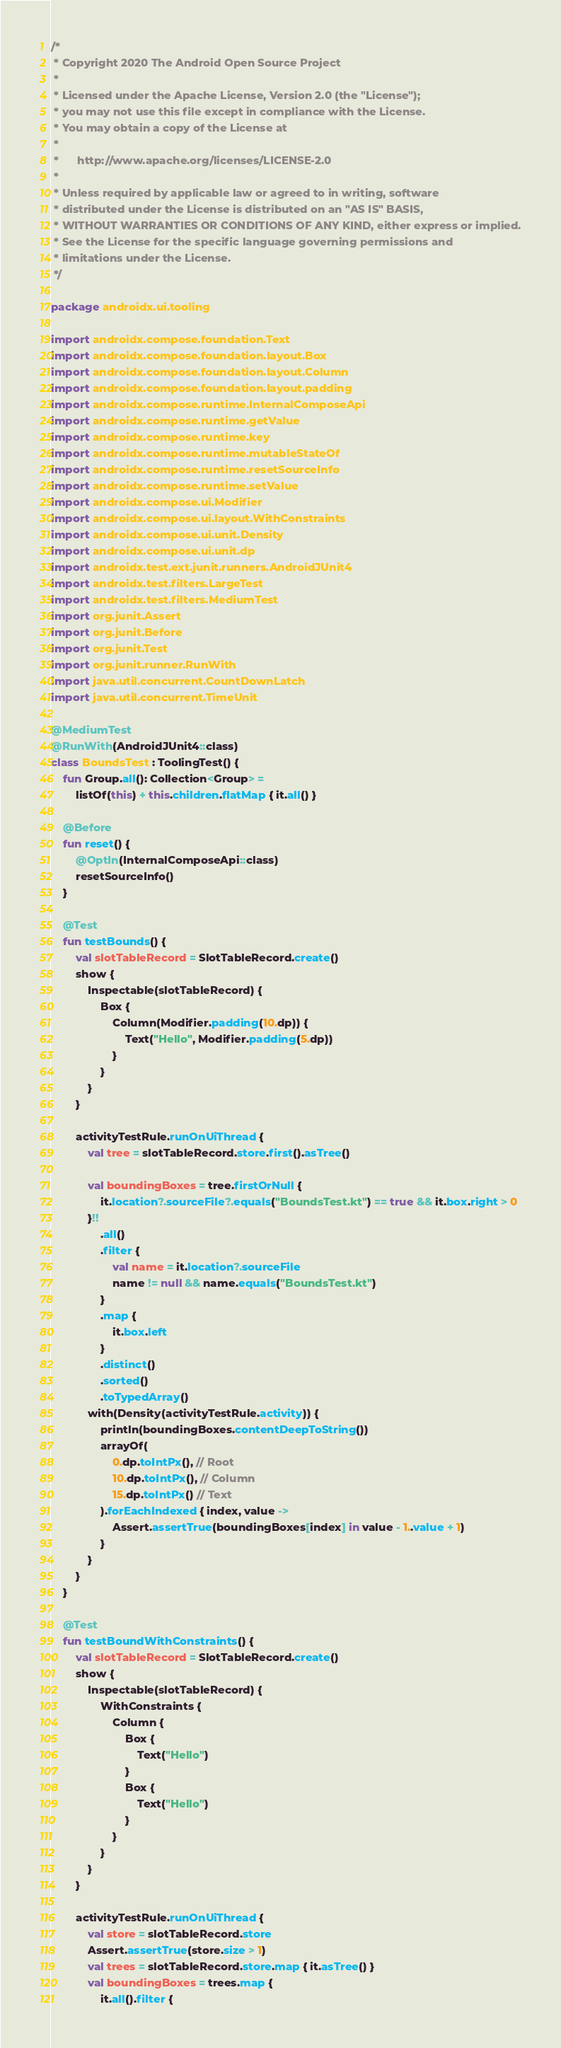Convert code to text. <code><loc_0><loc_0><loc_500><loc_500><_Kotlin_>/*
 * Copyright 2020 The Android Open Source Project
 *
 * Licensed under the Apache License, Version 2.0 (the "License");
 * you may not use this file except in compliance with the License.
 * You may obtain a copy of the License at
 *
 *      http://www.apache.org/licenses/LICENSE-2.0
 *
 * Unless required by applicable law or agreed to in writing, software
 * distributed under the License is distributed on an "AS IS" BASIS,
 * WITHOUT WARRANTIES OR CONDITIONS OF ANY KIND, either express or implied.
 * See the License for the specific language governing permissions and
 * limitations under the License.
 */

package androidx.ui.tooling

import androidx.compose.foundation.Text
import androidx.compose.foundation.layout.Box
import androidx.compose.foundation.layout.Column
import androidx.compose.foundation.layout.padding
import androidx.compose.runtime.InternalComposeApi
import androidx.compose.runtime.getValue
import androidx.compose.runtime.key
import androidx.compose.runtime.mutableStateOf
import androidx.compose.runtime.resetSourceInfo
import androidx.compose.runtime.setValue
import androidx.compose.ui.Modifier
import androidx.compose.ui.layout.WithConstraints
import androidx.compose.ui.unit.Density
import androidx.compose.ui.unit.dp
import androidx.test.ext.junit.runners.AndroidJUnit4
import androidx.test.filters.LargeTest
import androidx.test.filters.MediumTest
import org.junit.Assert
import org.junit.Before
import org.junit.Test
import org.junit.runner.RunWith
import java.util.concurrent.CountDownLatch
import java.util.concurrent.TimeUnit

@MediumTest
@RunWith(AndroidJUnit4::class)
class BoundsTest : ToolingTest() {
    fun Group.all(): Collection<Group> =
        listOf(this) + this.children.flatMap { it.all() }

    @Before
    fun reset() {
        @OptIn(InternalComposeApi::class)
        resetSourceInfo()
    }

    @Test
    fun testBounds() {
        val slotTableRecord = SlotTableRecord.create()
        show {
            Inspectable(slotTableRecord) {
                Box {
                    Column(Modifier.padding(10.dp)) {
                        Text("Hello", Modifier.padding(5.dp))
                    }
                }
            }
        }

        activityTestRule.runOnUiThread {
            val tree = slotTableRecord.store.first().asTree()

            val boundingBoxes = tree.firstOrNull {
                it.location?.sourceFile?.equals("BoundsTest.kt") == true && it.box.right > 0
            }!!
                .all()
                .filter {
                    val name = it.location?.sourceFile
                    name != null && name.equals("BoundsTest.kt")
                }
                .map {
                    it.box.left
                }
                .distinct()
                .sorted()
                .toTypedArray()
            with(Density(activityTestRule.activity)) {
                println(boundingBoxes.contentDeepToString())
                arrayOf(
                    0.dp.toIntPx(), // Root
                    10.dp.toIntPx(), // Column
                    15.dp.toIntPx() // Text
                ).forEachIndexed { index, value ->
                    Assert.assertTrue(boundingBoxes[index] in value - 1..value + 1)
                }
            }
        }
    }

    @Test
    fun testBoundWithConstraints() {
        val slotTableRecord = SlotTableRecord.create()
        show {
            Inspectable(slotTableRecord) {
                WithConstraints {
                    Column {
                        Box {
                            Text("Hello")
                        }
                        Box {
                            Text("Hello")
                        }
                    }
                }
            }
        }

        activityTestRule.runOnUiThread {
            val store = slotTableRecord.store
            Assert.assertTrue(store.size > 1)
            val trees = slotTableRecord.store.map { it.asTree() }
            val boundingBoxes = trees.map {
                it.all().filter {</code> 